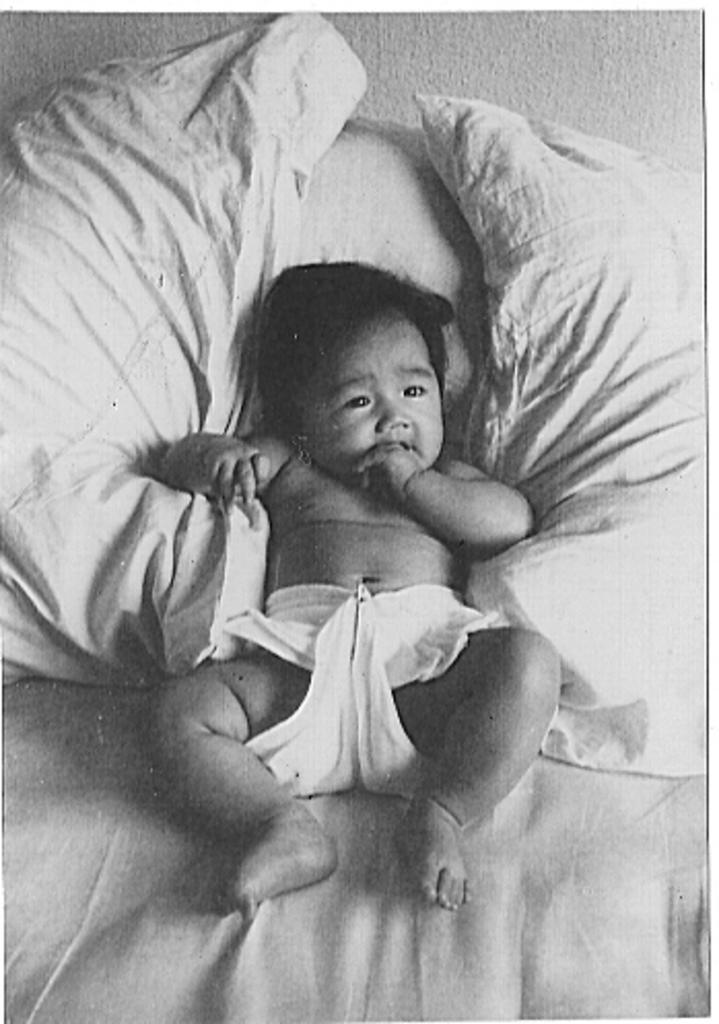What is the color scheme of the image? The image is black and white. What is the main subject of the image? There is a baby in the center of the image. Where is the baby located? The baby is on a bed. What else can be seen in the image? There are pillows in the image. What type of pancake is being served on the desk in the image? There is no pancake or desk present in the image. What substance is being used to clean the baby in the image? The image does not show any substance being used to clean the baby. 